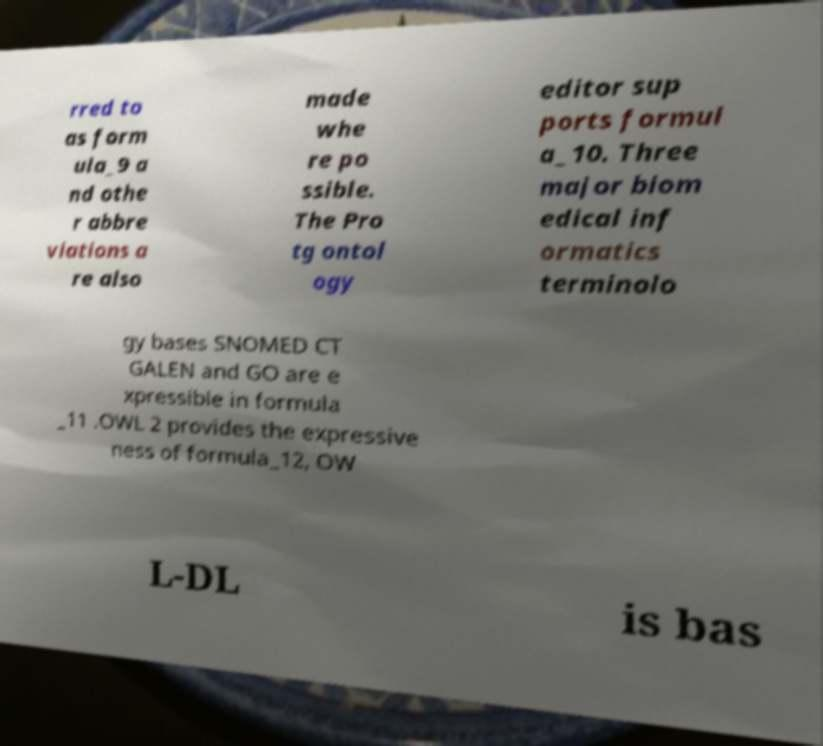I need the written content from this picture converted into text. Can you do that? rred to as form ula_9 a nd othe r abbre viations a re also made whe re po ssible. The Pro tg ontol ogy editor sup ports formul a_10. Three major biom edical inf ormatics terminolo gy bases SNOMED CT GALEN and GO are e xpressible in formula _11 .OWL 2 provides the expressive ness of formula_12, OW L-DL is bas 